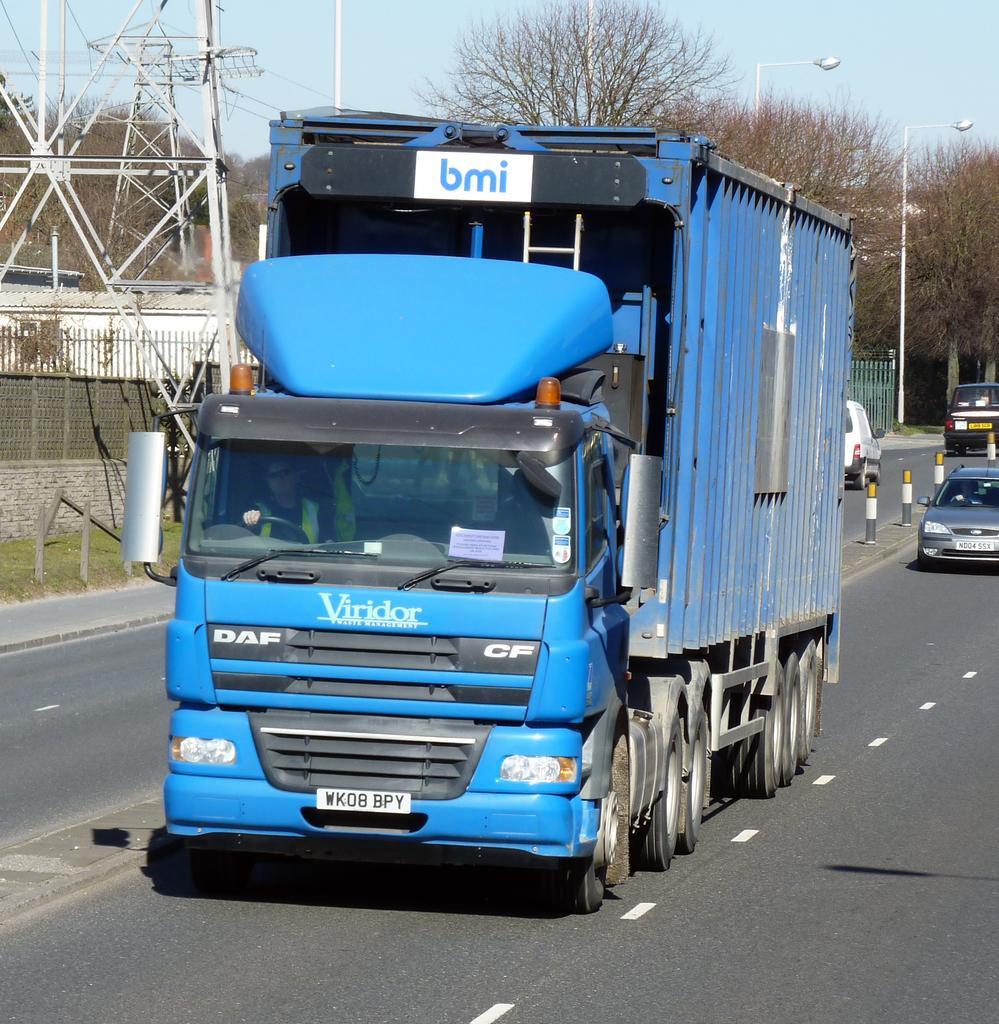Describe this image in one or two sentences. this picture shows a truck moving on a road and we see few trees and few vehicles and pole lights. 